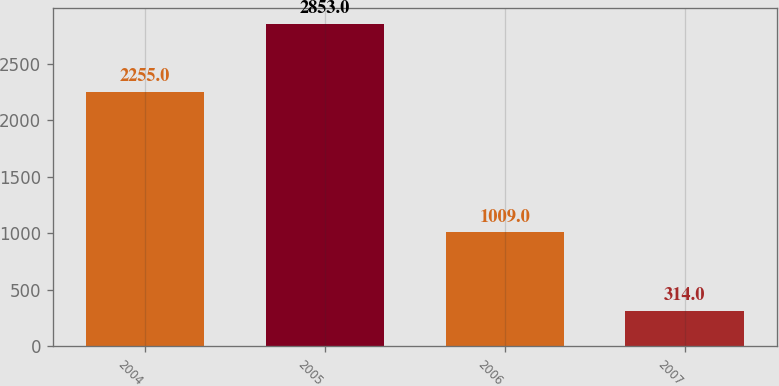Convert chart to OTSL. <chart><loc_0><loc_0><loc_500><loc_500><bar_chart><fcel>2004<fcel>2005<fcel>2006<fcel>2007<nl><fcel>2255<fcel>2853<fcel>1009<fcel>314<nl></chart> 